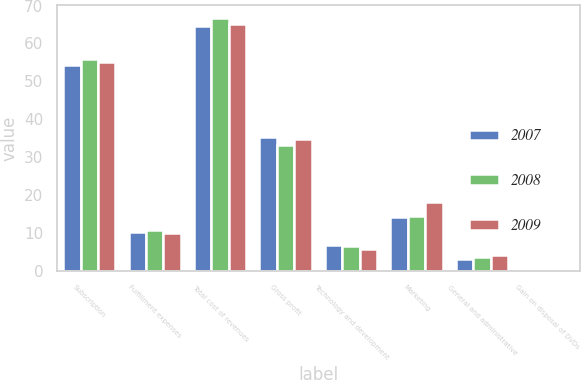<chart> <loc_0><loc_0><loc_500><loc_500><stacked_bar_chart><ecel><fcel>Subscription<fcel>Fulfillment expenses<fcel>Total cost of revenues<fcel>Gross profit<fcel>Technology and development<fcel>Marketing<fcel>General and administrative<fcel>Gain on disposal of DVDs<nl><fcel>2007<fcel>54.4<fcel>10.2<fcel>64.6<fcel>35.4<fcel>6.9<fcel>14.2<fcel>3.1<fcel>0.3<nl><fcel>2008<fcel>55.8<fcel>10.9<fcel>66.7<fcel>33.3<fcel>6.6<fcel>14.6<fcel>3.6<fcel>0.4<nl><fcel>2009<fcel>55.1<fcel>10.1<fcel>65.2<fcel>34.8<fcel>5.9<fcel>18.1<fcel>4.3<fcel>0.5<nl></chart> 